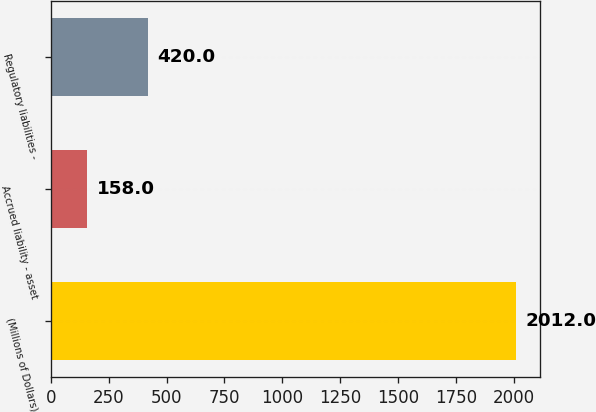<chart> <loc_0><loc_0><loc_500><loc_500><bar_chart><fcel>(Millions of Dollars)<fcel>Accrued liability - asset<fcel>Regulatory liabilities -<nl><fcel>2012<fcel>158<fcel>420<nl></chart> 